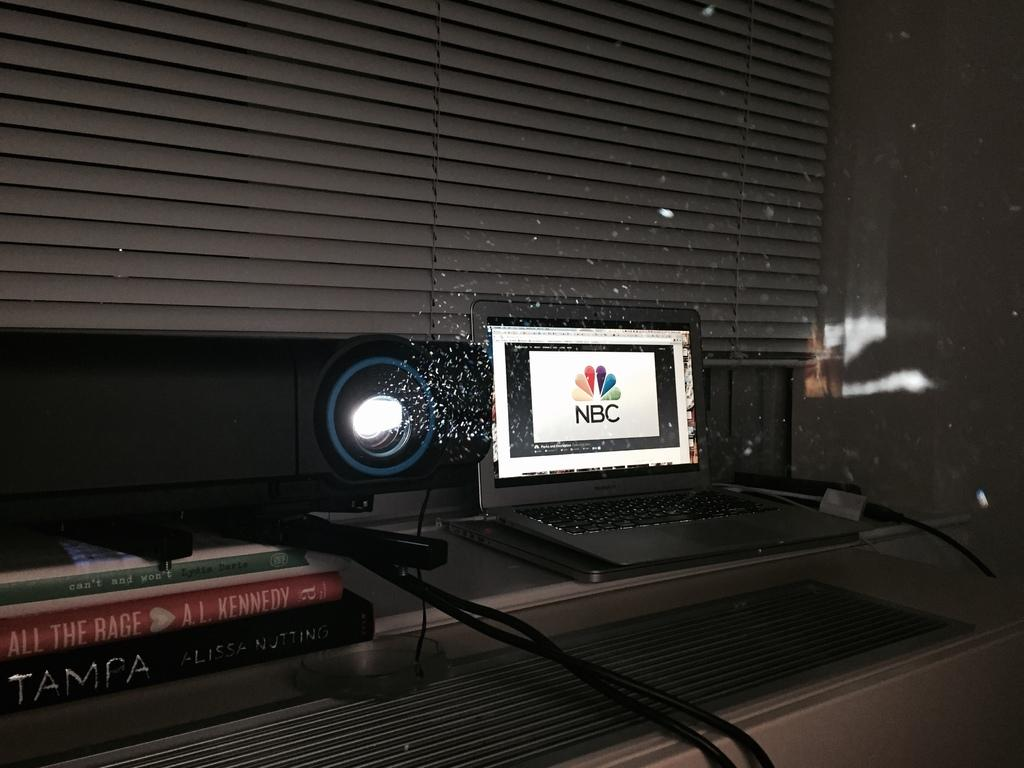Provide a one-sentence caption for the provided image. NBC showing on a computer monitor in a room. 